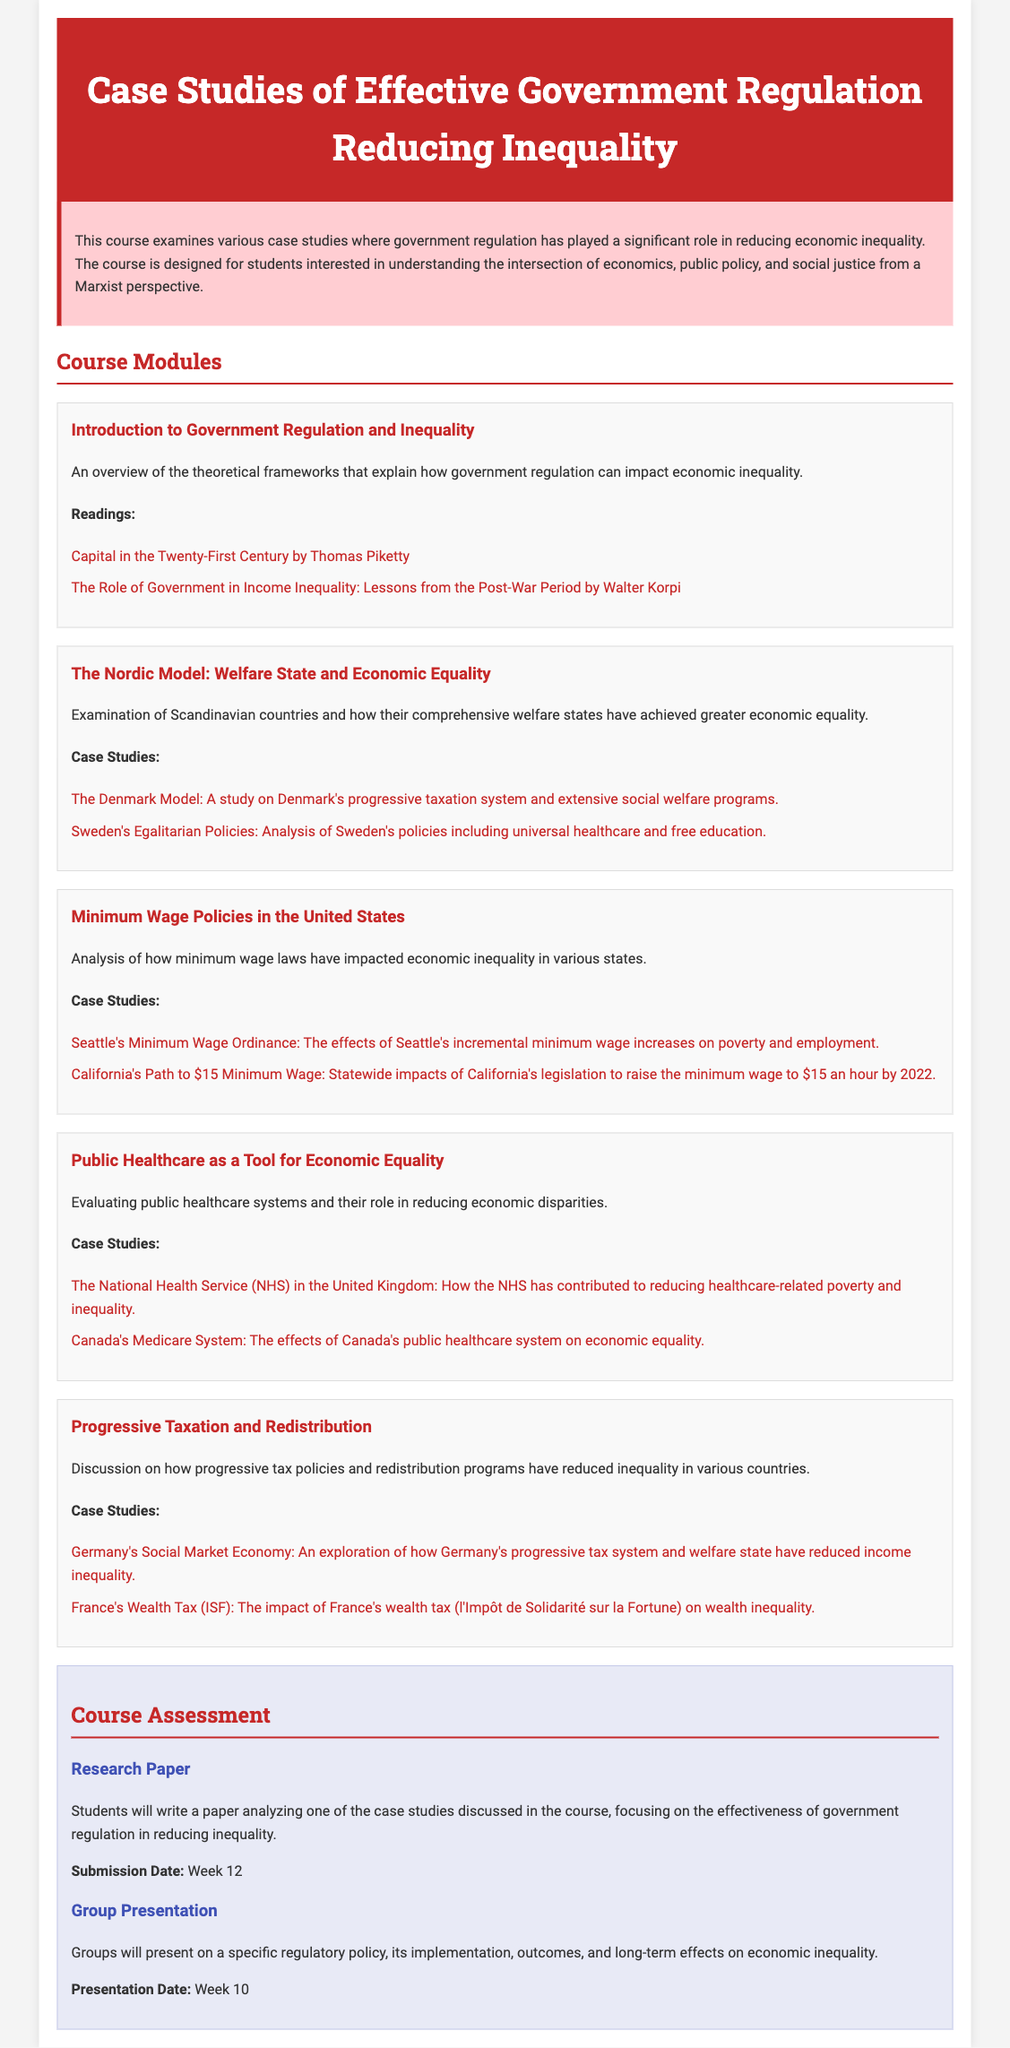What is the title of the course? The title is found in the header section of the document, highlighting the subject of the syllabus.
Answer: Case Studies of Effective Government Regulation Reducing Inequality What is the main focus of the course? The course description states that it examines government regulation's role in reducing inequality.
Answer: Government regulation reducing inequality Who is the course designed for? The course description specifies that it is for students interested in a specific perspective related to economics and public policy.
Answer: Students interested in economics, public policy, and social justice How many modules are in the course? The number of modules can be counted from the sections outlining various topics within the course.
Answer: Five What is one of the case studies in the module about the Nordic Model? The case studies section lists specific examples related to the Nordic model that can be referenced for answers.
Answer: The Denmark Model When is the submission date for the research paper? The assessment section provides a specific date for when the research paper is due.
Answer: Week 12 What type of tax policy is discussed in the Progressive Taxation and Redistribution module? The title of the module indicates the focus on a particular type of taxation aimed at reducing inequality.
Answer: Progressive tax policies What is a primary topic of the Public Healthcare module? The description of the module summarizes its focus and connection to economic equality.
Answer: Evaluating public healthcare systems Which country is analyzed in the case study related to the NHS? The list of case studies provides specific countries being studied for their government regulation effectiveness.
Answer: United Kingdom 